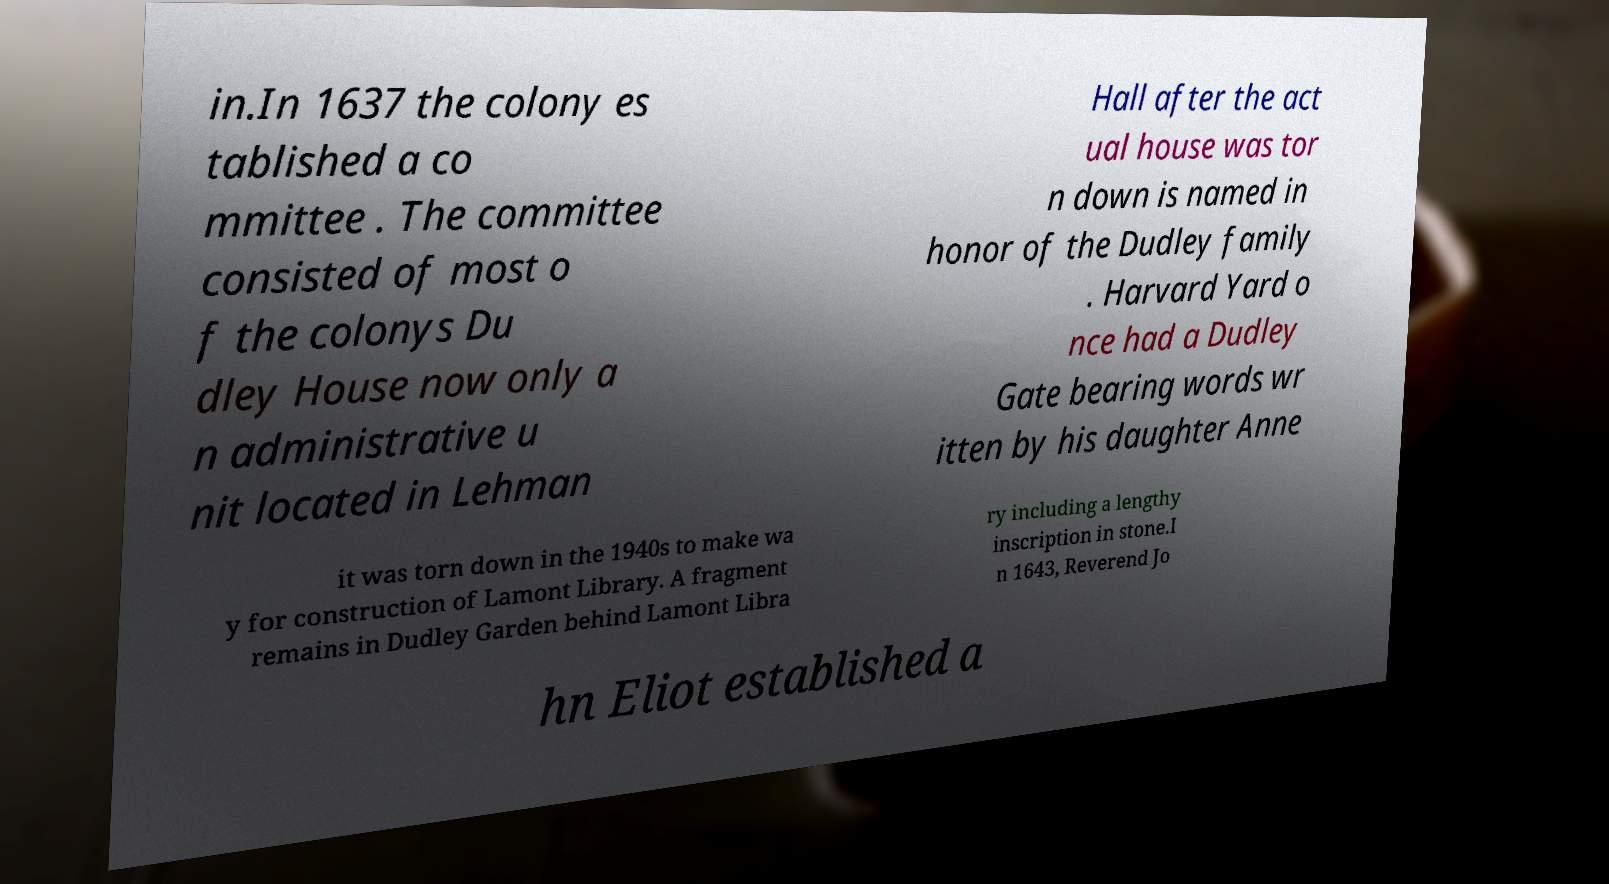Please identify and transcribe the text found in this image. in.In 1637 the colony es tablished a co mmittee . The committee consisted of most o f the colonys Du dley House now only a n administrative u nit located in Lehman Hall after the act ual house was tor n down is named in honor of the Dudley family . Harvard Yard o nce had a Dudley Gate bearing words wr itten by his daughter Anne it was torn down in the 1940s to make wa y for construction of Lamont Library. A fragment remains in Dudley Garden behind Lamont Libra ry including a lengthy inscription in stone.I n 1643, Reverend Jo hn Eliot established a 